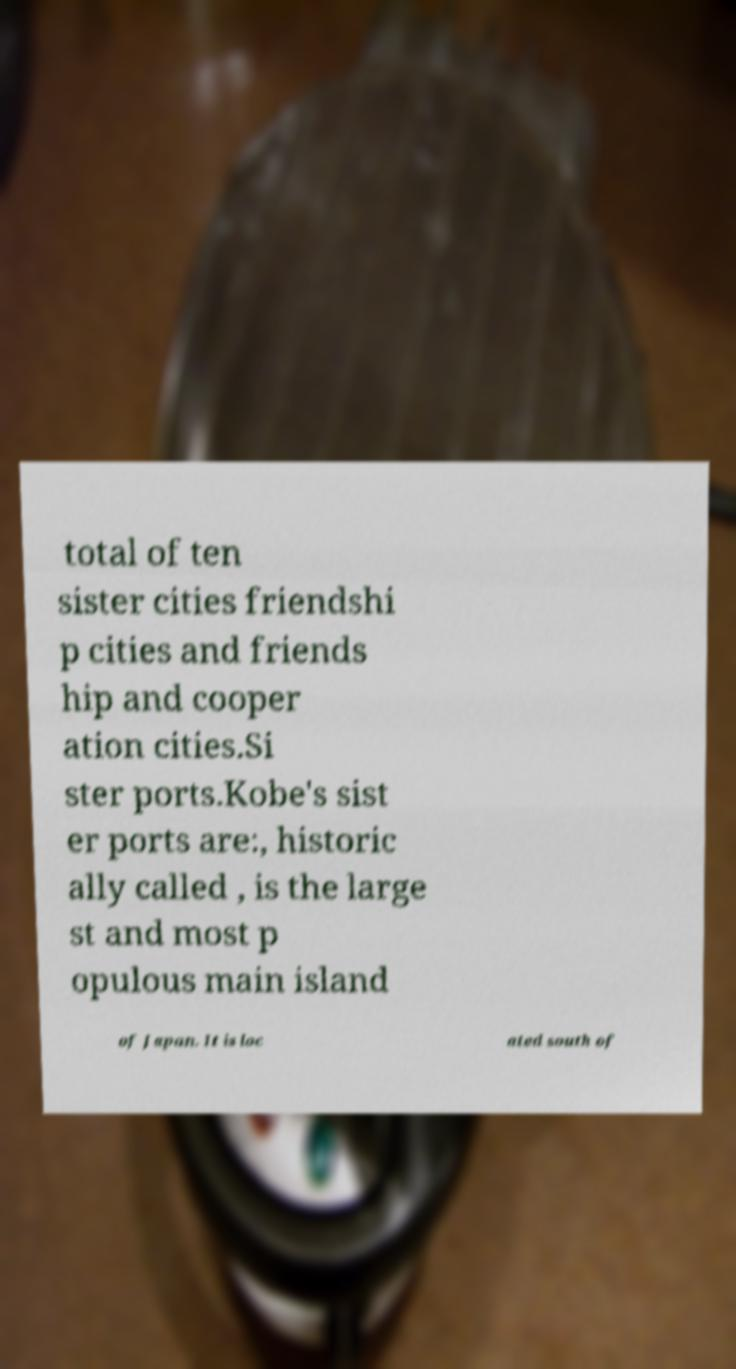What messages or text are displayed in this image? I need them in a readable, typed format. total of ten sister cities friendshi p cities and friends hip and cooper ation cities.Si ster ports.Kobe's sist er ports are:, historic ally called , is the large st and most p opulous main island of Japan. It is loc ated south of 